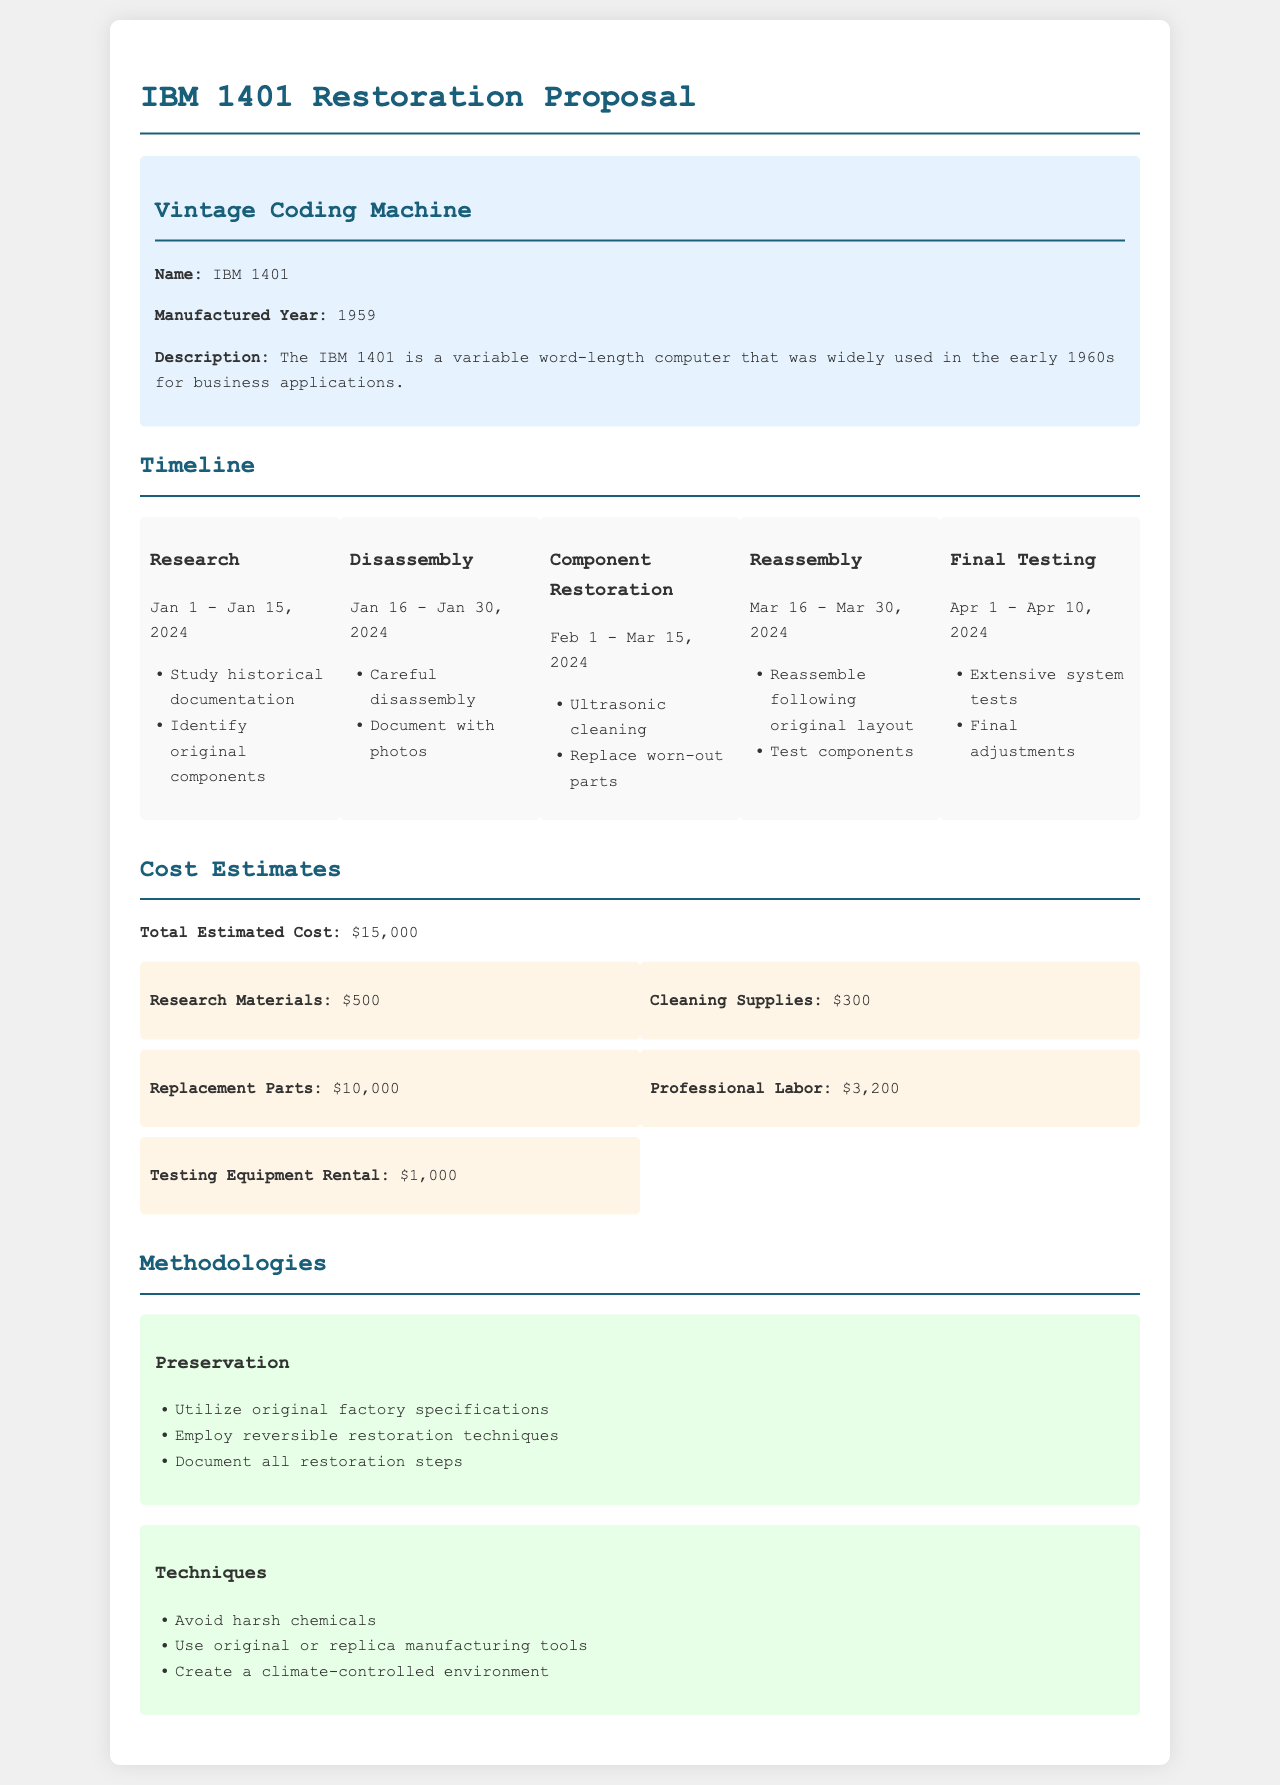What is the name of the vintage coding machine? The name of the vintage coding machine is stated in the document.
Answer: IBM 1401 When was the IBM 1401 manufactured? The manufacturing year of the IBM 1401 is provided in the document.
Answer: 1959 What is the total estimated cost for the restoration? The total estimated cost is clearly indicated in the costing section of the document.
Answer: $15,000 How long is the research phase scheduled to last? The duration of the research phase can be calculated from the timeline provided in the document.
Answer: 15 days What method will be used to clean the parts? The methodology section of the document mentions the cleaning method.
Answer: Ultrasonic cleaning What percentage of the total cost is allocated to replacement parts? This requires performing a calculation based on the total estimate and the cost for replacement parts listed in the document.
Answer: Approximately 66.67% What is one technique to avoid during restoration? The methodologies section suggests specific techniques to employ or avoid during restoration.
Answer: Harsh chemicals What type of environment is recommended for restoration? The methodologies section specifies the type of environment that should be created for the restoration process.
Answer: Climate-controlled environment 